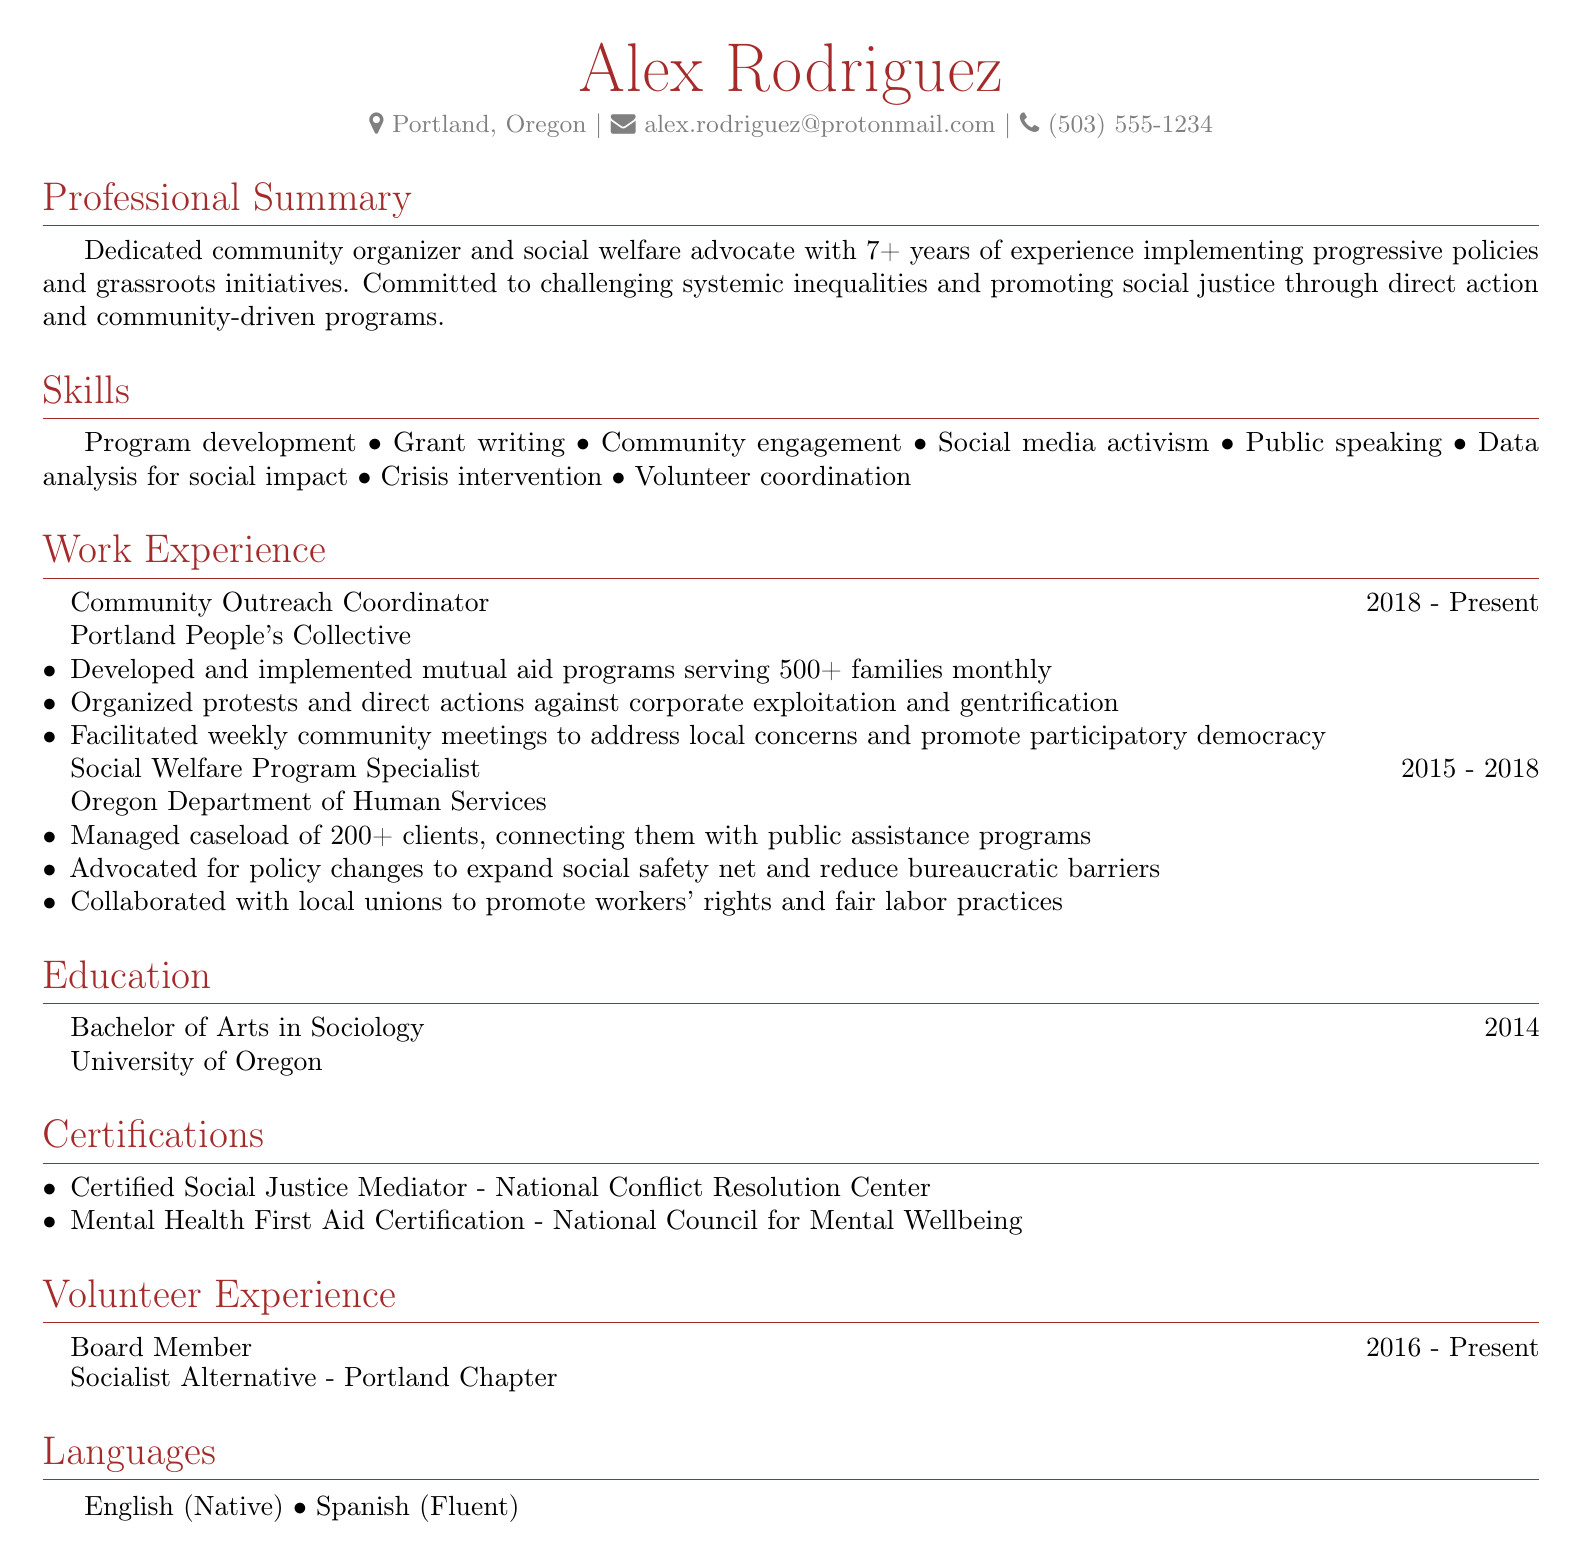What is the name of the individual? The document contains the personal information section where the individual's name is stated.
Answer: Alex Rodriguez What city is the individual located in? The location is mentioned in the personal information section of the CV.
Answer: Portland, Oregon How many years of experience does the individual have? The professional summary section states the number of years of experience.
Answer: 7+ What was the role of the individual from 2015 to 2018? The work experience section lists the individual's previous positions and durations.
Answer: Social Welfare Program Specialist Which organization does the individual currently work for? The work experience section indicates the current position and organization.
Answer: Portland People's Collective What type of degree did the individual attain? The education section outlines the degree earned by the individual.
Answer: Bachelor of Arts in Sociology How many clients did the individual manage in the past role? The document specifies the caseload managed in the work experience section.
Answer: 200+ What certifications does the individual hold? The certifications section lists specific certifications achieved by the individual.
Answer: Certified Social Justice Mediator, Mental Health First Aid Certification What language is the individual fluent in besides English? The languages section specifies the spoken languages.
Answer: Spanish What local issues has the individual organized protests against? The work experience section mentions the issues associated with the individual's actions.
Answer: Corporate exploitation and gentrification 